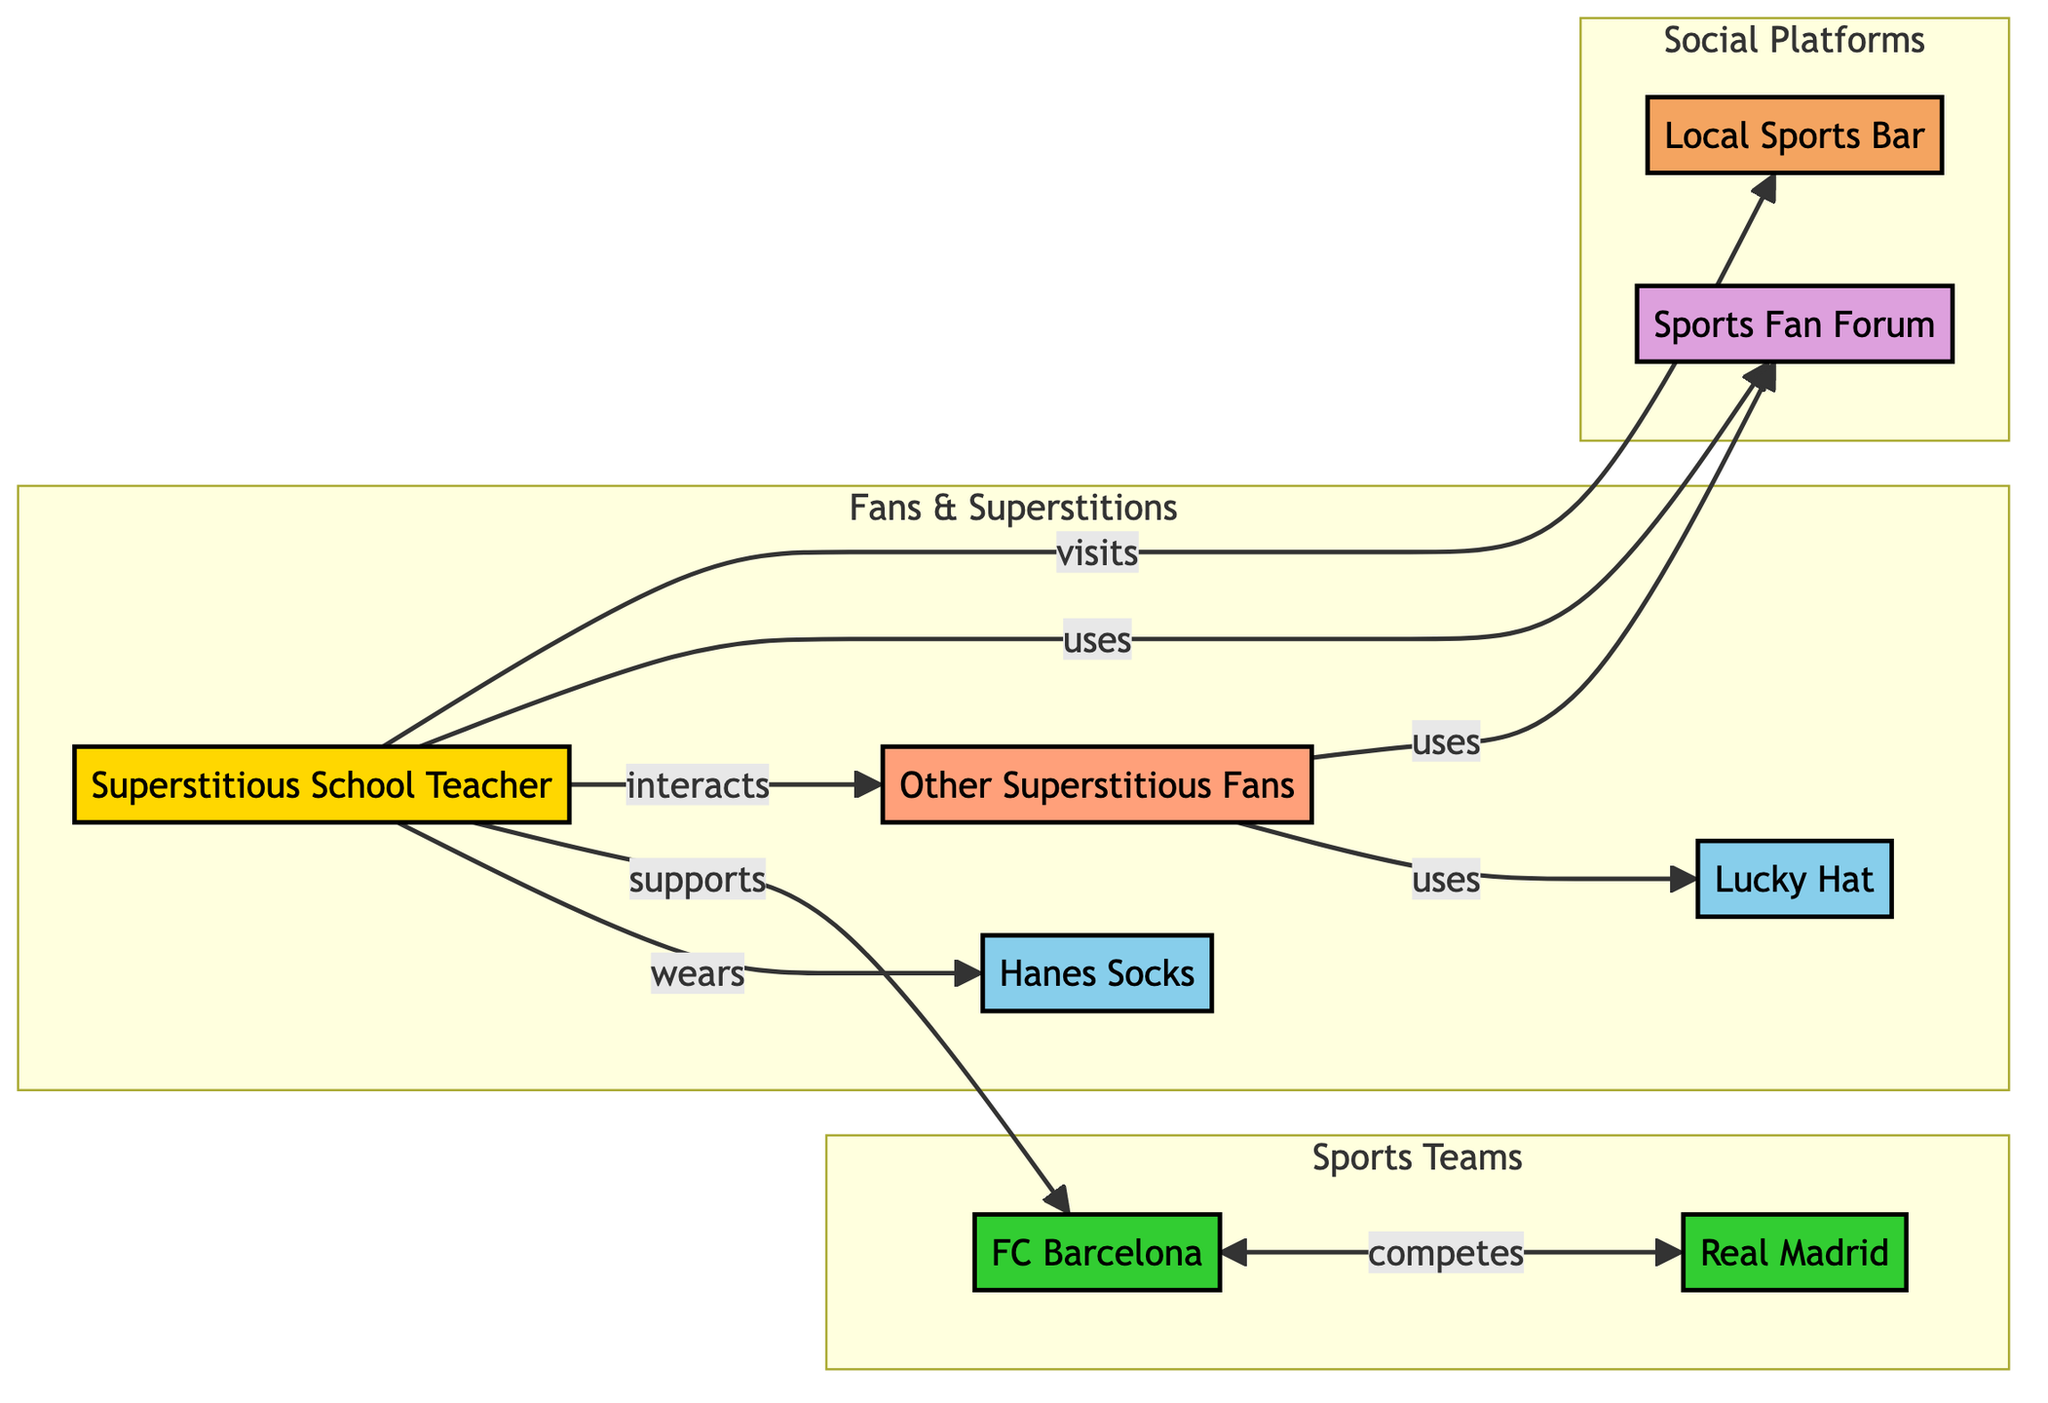What's the number of nodes in the diagram? The diagram consists of eight distinct nodes, representing various entities such as the Teacher, sock brand, sports teams, other fans, etc.
Answer: 8 What relationship does the teacher have with the soccer team? The teacher supports the soccer team, indicated by the directed edge from the teacher to the soccer team labeled "supports."
Answer: supports Which socks does the teacher wear? The teacher wears Hanes Socks, as shown by the edge labeled "wears" connecting the teacher to the sock brand.
Answer: Hanes Socks What do other fans use for superstitions? Other fans use a Lucky Hat, as indicated by the directed edge from other fans to the lucky hat labeled "uses."
Answer: Lucky Hat How many edges are in the diagram? There are seven directed edges in the diagram, representing various relationships among the nodes, such as wearing, supporting, and using.
Answer: 7 What type of location is the local sports bar? The Local Sports Bar is classified as a Location in the diagram, indicated by its categorization in the nodes section.
Answer: Location Who visits the local sports bar? The teacher visits the local sports bar, as shown by the directed edge labeled "visits" from the teacher to the sports bar.
Answer: teacher What is the purpose of the Sports Fan Forum? The Sports Fan Forum serves as a platform to share superstitions and game-day rituals, which is depicted by the edge leading to the forum.
Answer: share superstitions Which sports teams are involved in competition? The sports teams involved in competition are FC Barcelona and Real Madrid, as indicated by the edge labeled "competes" connecting them.
Answer: FC Barcelona and Real Madrid How do other fans interact with the teacher? Other fans interact with the teacher as depicted by the directed edge labeled "interacts" connecting them.
Answer: interacts 